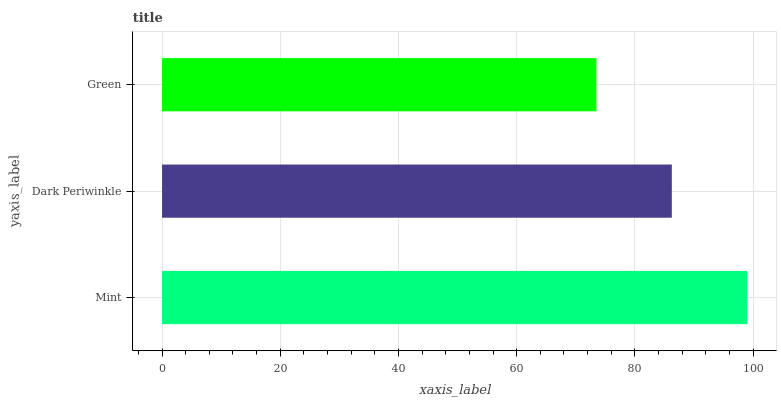Is Green the minimum?
Answer yes or no. Yes. Is Mint the maximum?
Answer yes or no. Yes. Is Dark Periwinkle the minimum?
Answer yes or no. No. Is Dark Periwinkle the maximum?
Answer yes or no. No. Is Mint greater than Dark Periwinkle?
Answer yes or no. Yes. Is Dark Periwinkle less than Mint?
Answer yes or no. Yes. Is Dark Periwinkle greater than Mint?
Answer yes or no. No. Is Mint less than Dark Periwinkle?
Answer yes or no. No. Is Dark Periwinkle the high median?
Answer yes or no. Yes. Is Dark Periwinkle the low median?
Answer yes or no. Yes. Is Mint the high median?
Answer yes or no. No. Is Mint the low median?
Answer yes or no. No. 